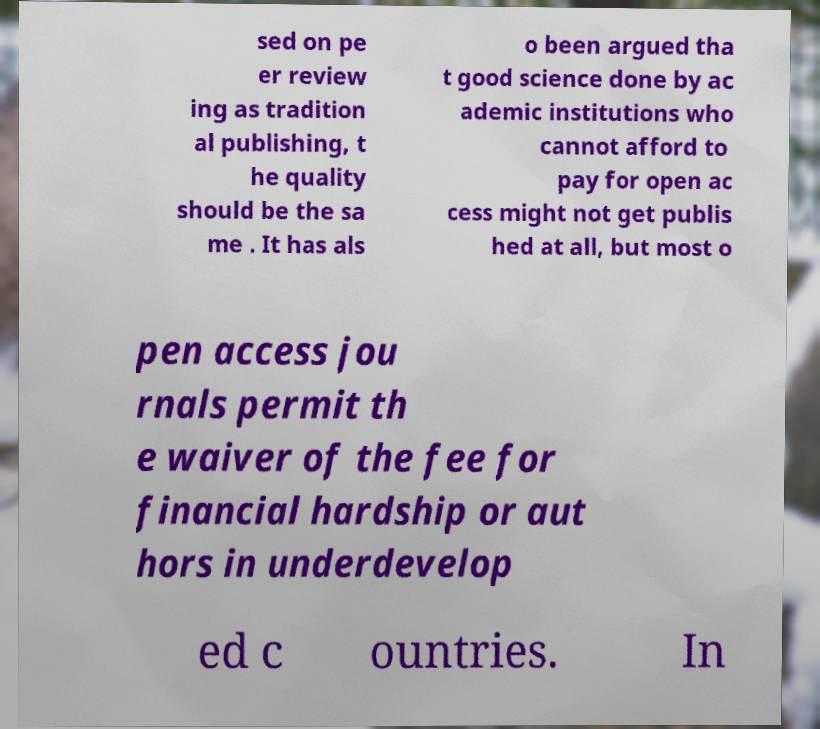Could you extract and type out the text from this image? sed on pe er review ing as tradition al publishing, t he quality should be the sa me . It has als o been argued tha t good science done by ac ademic institutions who cannot afford to pay for open ac cess might not get publis hed at all, but most o pen access jou rnals permit th e waiver of the fee for financial hardship or aut hors in underdevelop ed c ountries. In 